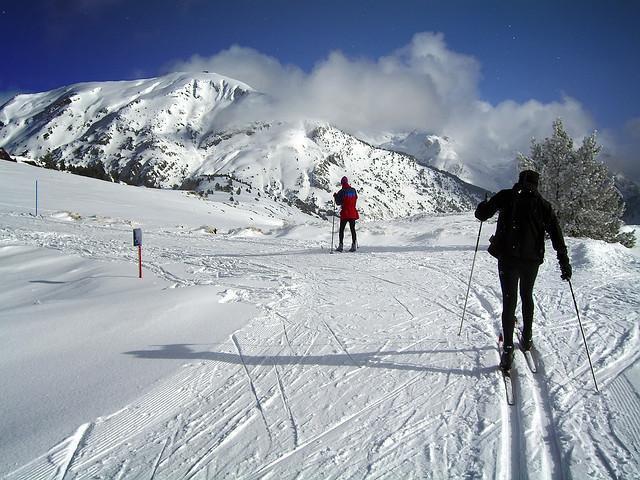What is misting up from the mountain?
Select the accurate answer and provide justification: `Answer: choice
Rationale: srationale.`
Options: Man's breath, city smog, smoke, fog. Answer: fog.
Rationale: There is a mountain with a white, cloud looking formations in the sky around the peaks. fog is common at higher elevations. 